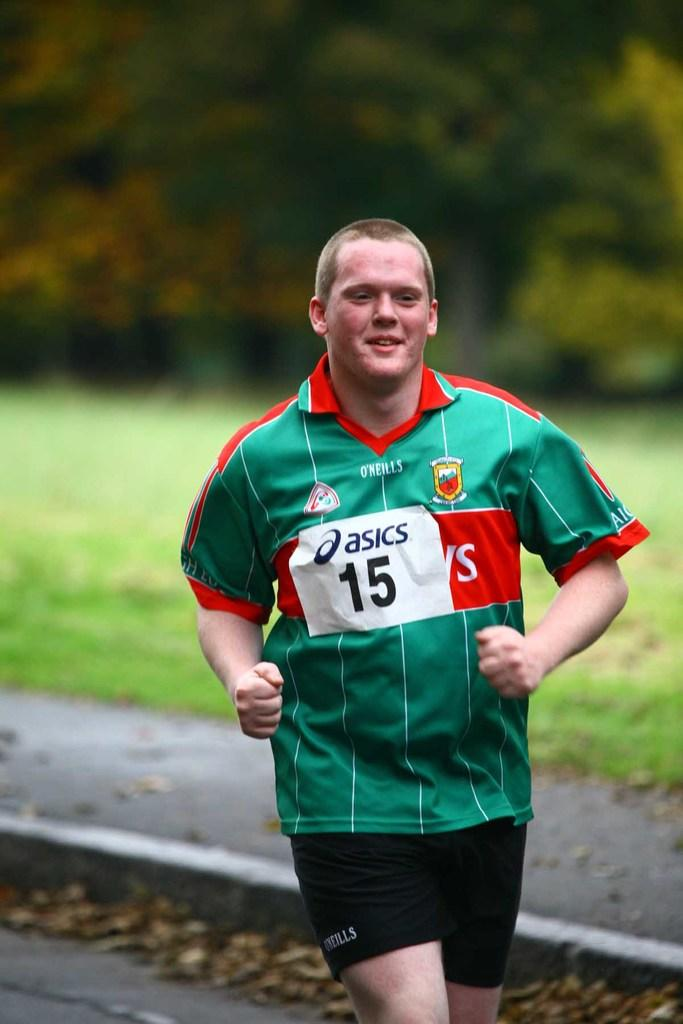What is the person in the image doing? The person is running in the image. On what surface is the person running? The person is running on a road. What type of vegetation is visible behind the person? There is grass on the surface behind the person. What can be seen in the distance in the image? There are trees in the background of the image. What type of shop can be seen in the image? There is no shop present in the image; it features a person running on a road with grass and trees in the background. 